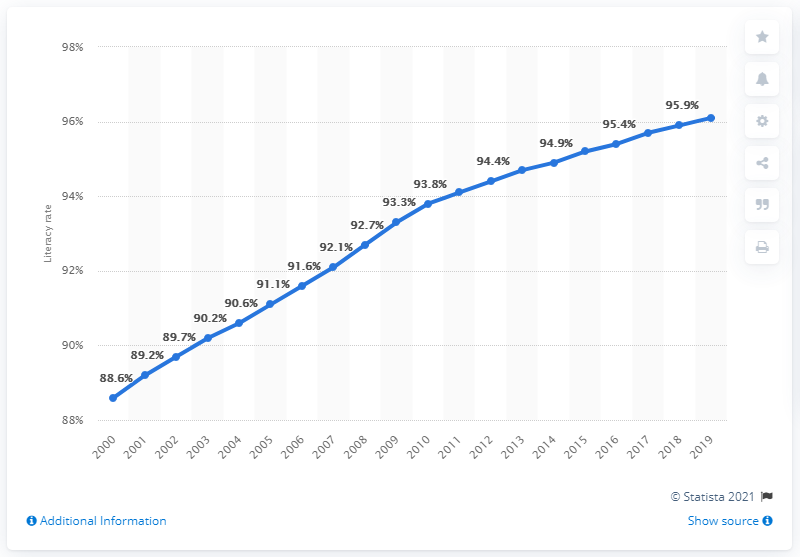Point out several critical features in this image. In 2019, the literacy rate for females in Singapore was 96.1%. 